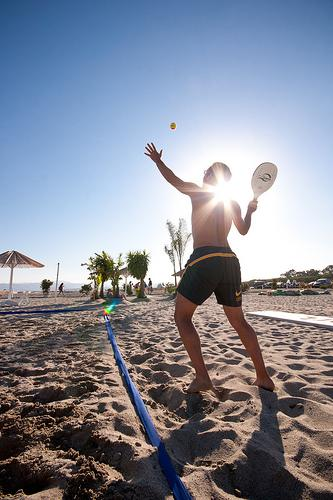Question: what is on the ground?
Choices:
A. Dirt.
B. Money.
C. Sand.
D. Dice.
Answer with the letter. Answer: C Question: where is the picture taken?
Choices:
A. The beach.
B. Disneyworld.
C. Disneyland.
D. Bahamas.
Answer with the letter. Answer: A Question: why is the person holding a paddle?
Choices:
A. For badminton.
B. Frat initiation.
C. They are playing a game.
D. Discipline.
Answer with the letter. Answer: C Question: who is holding a paddle?
Choices:
A. The person.
B. The principle.
C. The player.
D. The kid.
Answer with the letter. Answer: A 